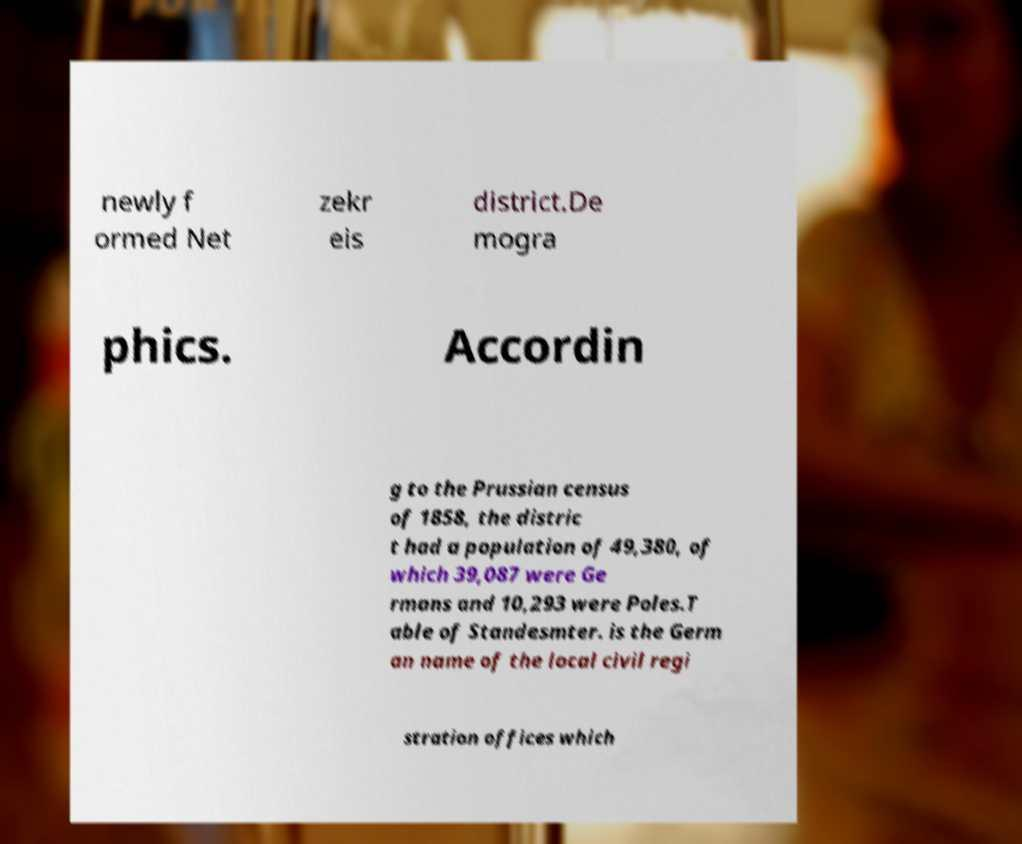Please read and relay the text visible in this image. What does it say? newly f ormed Net zekr eis district.De mogra phics. Accordin g to the Prussian census of 1858, the distric t had a population of 49,380, of which 39,087 were Ge rmans and 10,293 were Poles.T able of Standesmter. is the Germ an name of the local civil regi stration offices which 